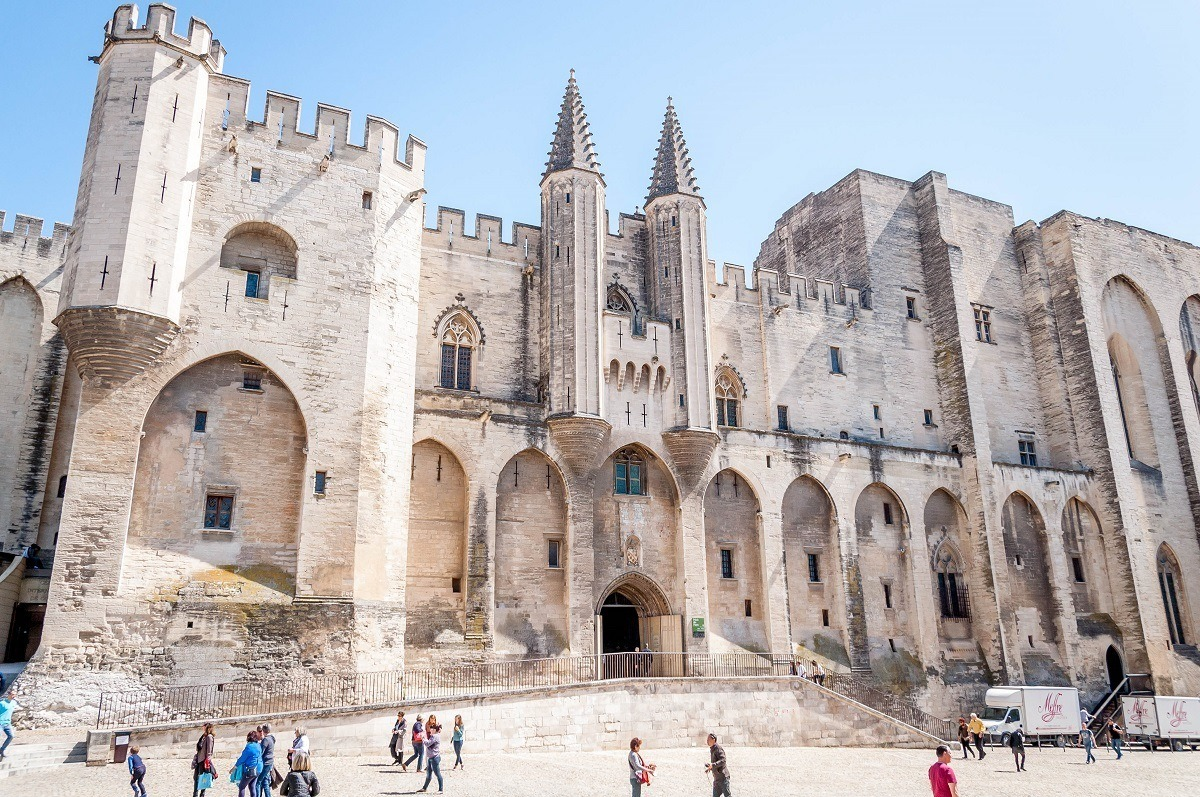What's happening in the scene? The image captures the magnificence of the Papal Palace in Avignon, France. This imposing medieval Gothic structure stands tall under the bright sunlight, its light-colored stone glistening against the clear blue sky. The palace is a majestic sight with its numerous towers, spires, and a grand arched entrance, which serve as a testament to its historical importance. The scene is brought to life with people casually strolling in front of the palace, and a truck parked on the side, blending the historic grandeur with contemporary daily activities. The juxtaposition of the ancient palace with modern-day life vividly illustrates the continuity of history and the vibrancy of current times. 